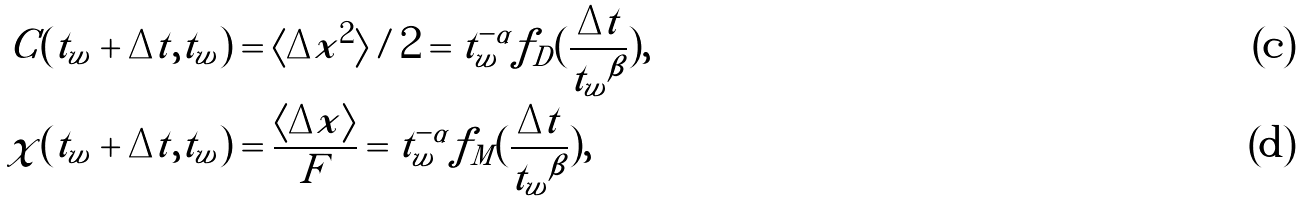<formula> <loc_0><loc_0><loc_500><loc_500>C ( t _ { w } + \Delta t , t _ { w } ) & = \langle \Delta x ^ { 2 } \rangle / 2 = t _ { w } ^ { - \alpha } f _ { D } ( \frac { \Delta t } { { t _ { w } } ^ { \beta } } ) , \\ \chi ( t _ { w } + \Delta t , t _ { w } ) & = \frac { \langle \Delta x \rangle } { F } = t _ { w } ^ { - \alpha } f _ { M } ( \frac { \Delta t } { { t _ { w } } ^ { \beta } } ) ,</formula> 